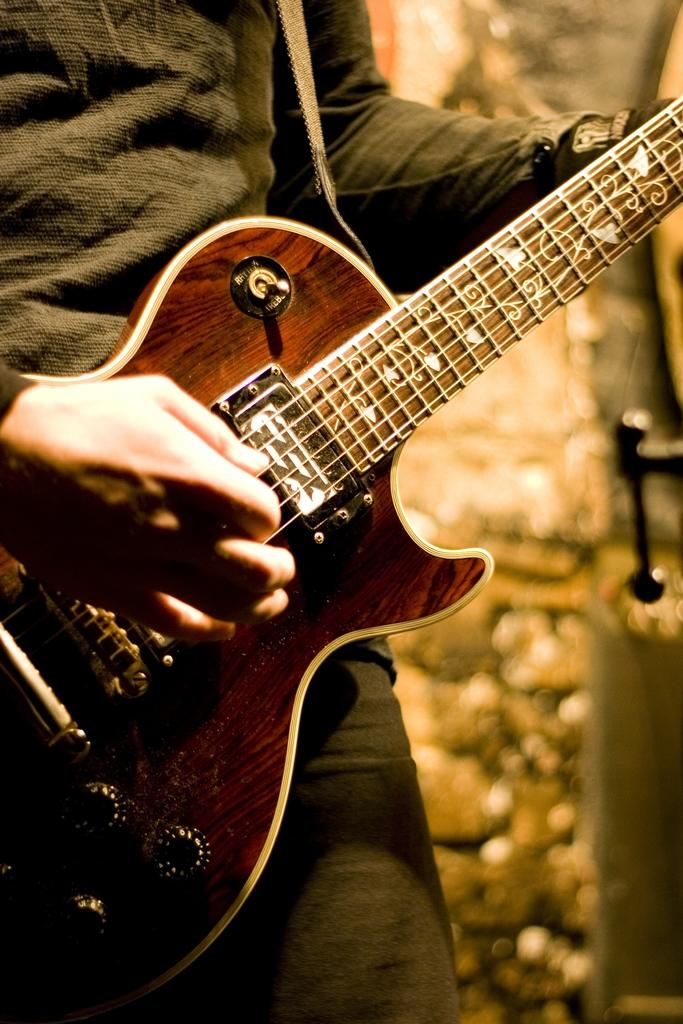What is the main subject of the image? There is a person in the image. What is the person holding in the image? The person is holding a guitar. What type of garden can be seen in the image? There is no garden present in the image; it features a person holding a guitar. What kind of pie is the person eating in the image? There is no pie present in the image; the person is holding a guitar. 